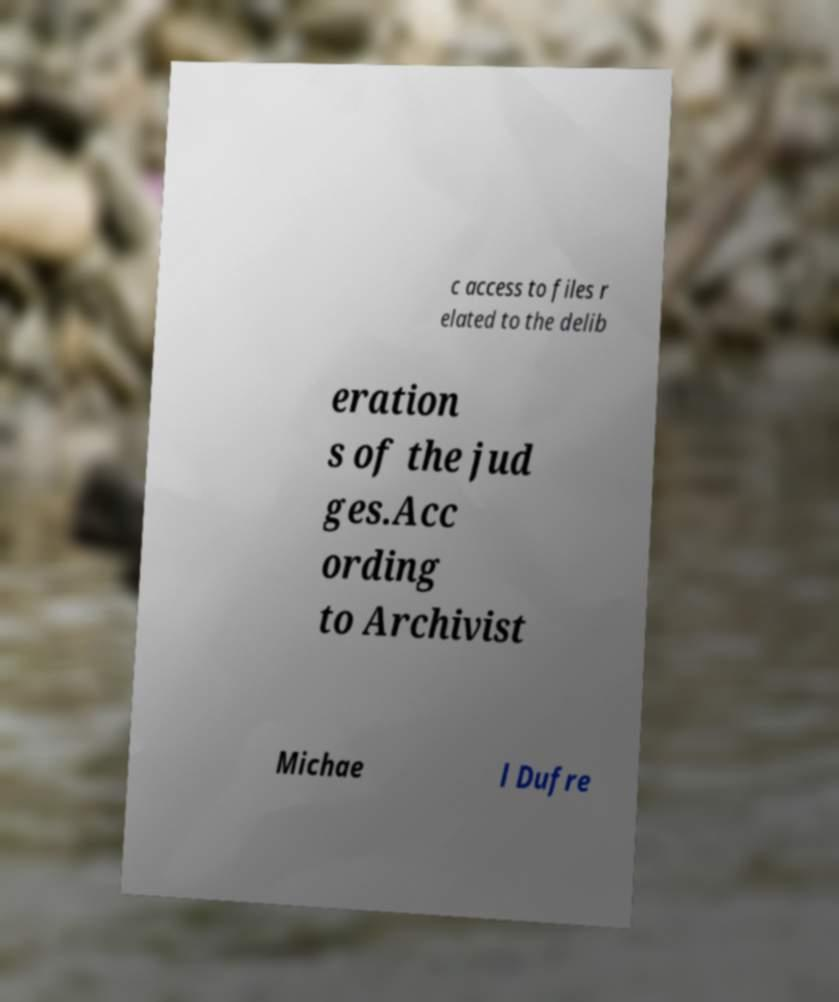There's text embedded in this image that I need extracted. Can you transcribe it verbatim? c access to files r elated to the delib eration s of the jud ges.Acc ording to Archivist Michae l Dufre 